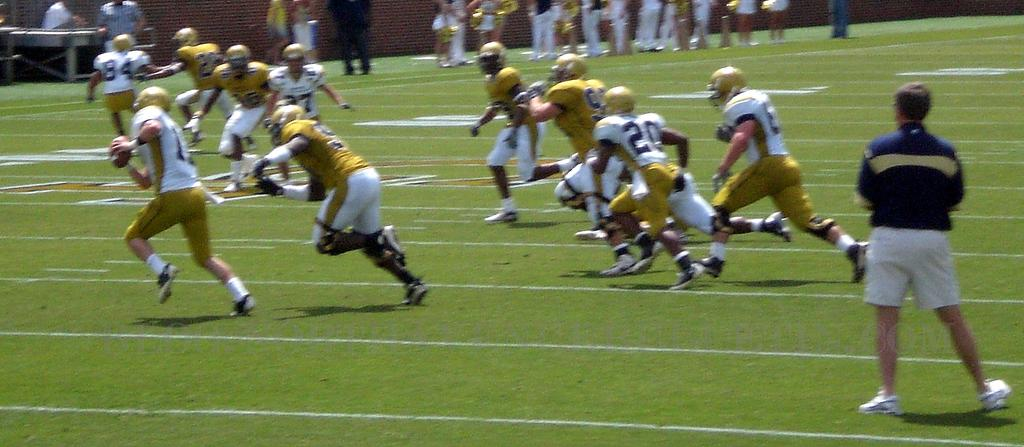What activity is taking place in the image? There are players playing in a ground. What can be seen in the background of the image? There is a wall and a table in the background of the image. Are there any other people visible in the image? Yes, there are persons in the background of the image. What type of milk is being served for lunch in the image? There is no mention of milk or lunch in the image; it features players playing in a ground with a background that includes a wall and a table. 